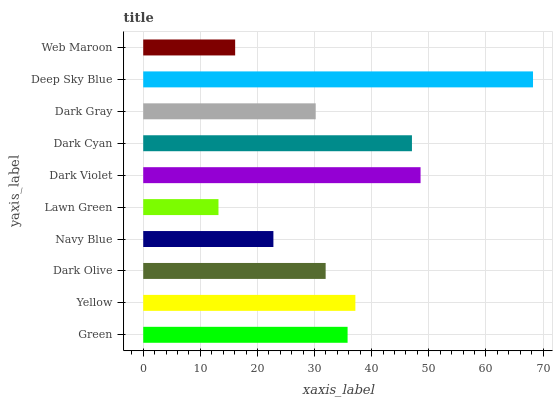Is Lawn Green the minimum?
Answer yes or no. Yes. Is Deep Sky Blue the maximum?
Answer yes or no. Yes. Is Yellow the minimum?
Answer yes or no. No. Is Yellow the maximum?
Answer yes or no. No. Is Yellow greater than Green?
Answer yes or no. Yes. Is Green less than Yellow?
Answer yes or no. Yes. Is Green greater than Yellow?
Answer yes or no. No. Is Yellow less than Green?
Answer yes or no. No. Is Green the high median?
Answer yes or no. Yes. Is Dark Olive the low median?
Answer yes or no. Yes. Is Dark Cyan the high median?
Answer yes or no. No. Is Lawn Green the low median?
Answer yes or no. No. 